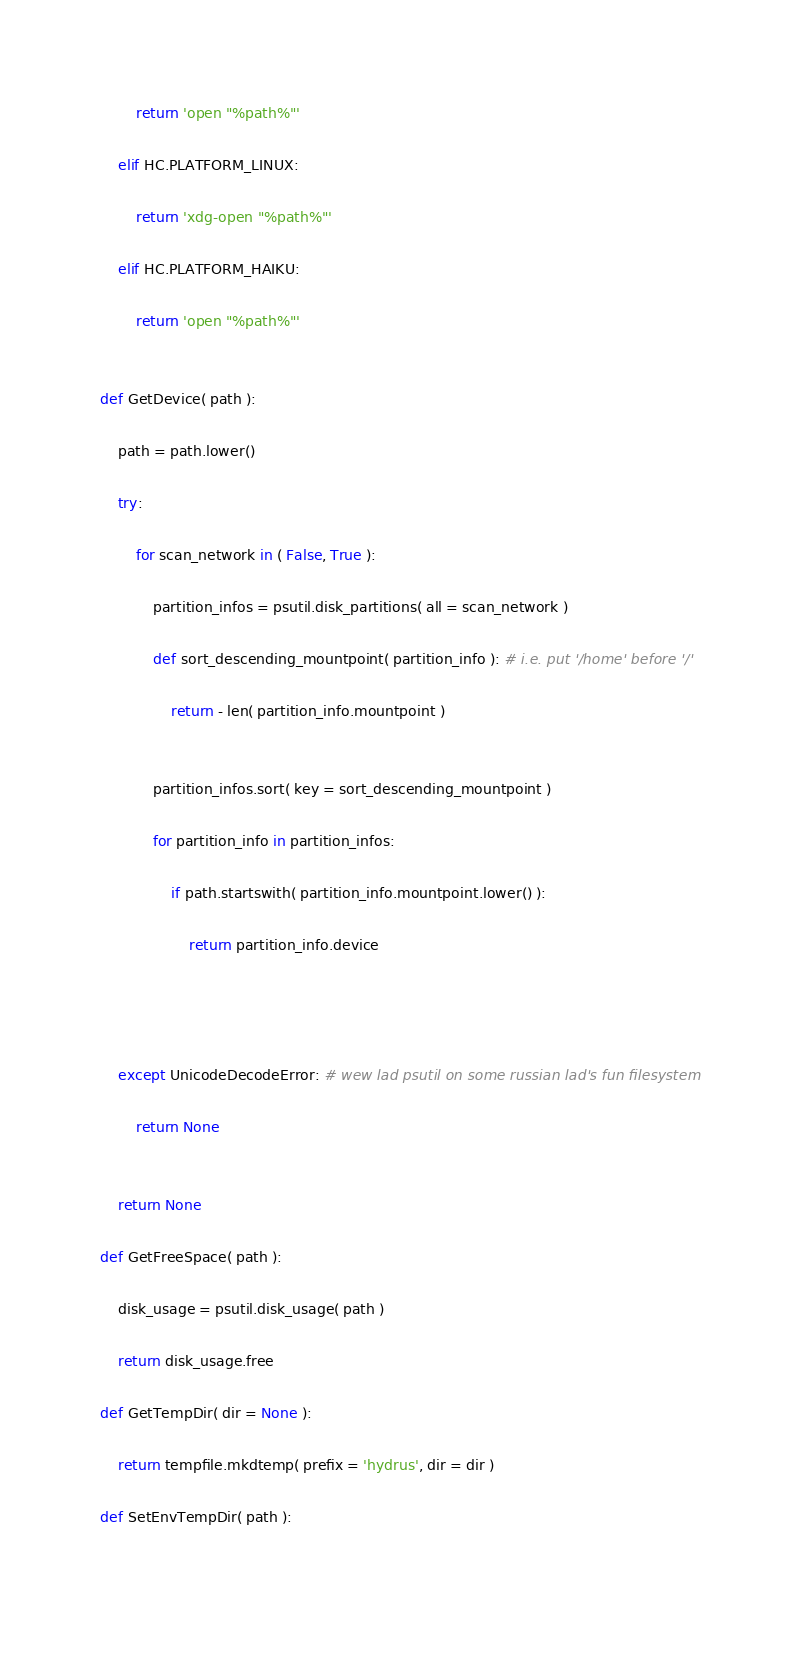Convert code to text. <code><loc_0><loc_0><loc_500><loc_500><_Python_>        return 'open "%path%"'
        
    elif HC.PLATFORM_LINUX:
        
        return 'xdg-open "%path%"'
        
    elif HC.PLATFORM_HAIKU:
        
        return 'open "%path%"'
        
    
def GetDevice( path ):
    
    path = path.lower()
    
    try:
        
        for scan_network in ( False, True ):
            
            partition_infos = psutil.disk_partitions( all = scan_network )
            
            def sort_descending_mountpoint( partition_info ): # i.e. put '/home' before '/'
                
                return - len( partition_info.mountpoint )
                
            
            partition_infos.sort( key = sort_descending_mountpoint )
            
            for partition_info in partition_infos:
                
                if path.startswith( partition_info.mountpoint.lower() ):
                    
                    return partition_info.device
                    
                
            
        
    except UnicodeDecodeError: # wew lad psutil on some russian lad's fun filesystem
        
        return None
        
    
    return None
    
def GetFreeSpace( path ):
    
    disk_usage = psutil.disk_usage( path )
    
    return disk_usage.free
    
def GetTempDir( dir = None ):
    
    return tempfile.mkdtemp( prefix = 'hydrus', dir = dir )
    
def SetEnvTempDir( path ):
    </code> 